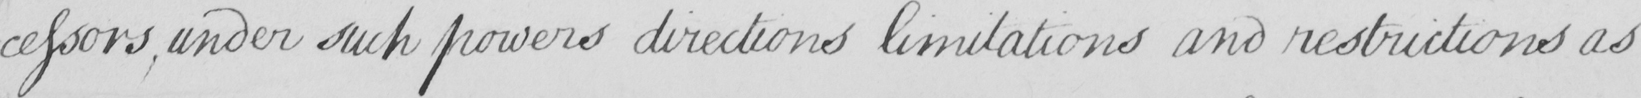Please provide the text content of this handwritten line. -cessors , under such powers directions limitations and restrictions as 